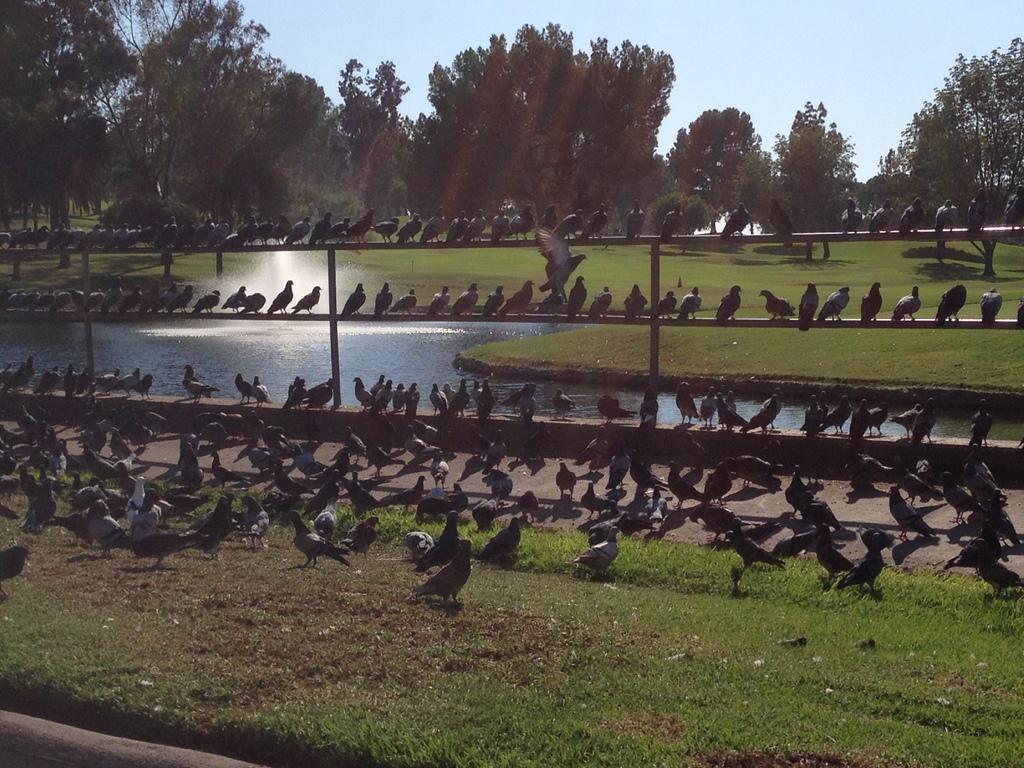Can you describe this image briefly? In the image I can see birds among them some are on the ground and some are sitting on fence. In the background I can see the grass, the water, trees and the sky. 